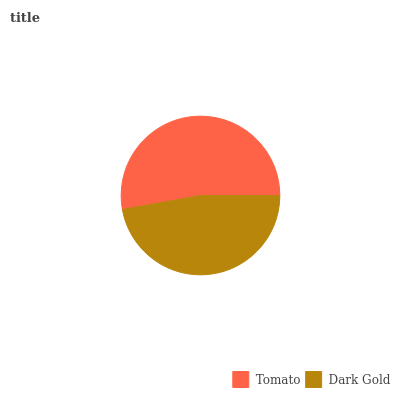Is Dark Gold the minimum?
Answer yes or no. Yes. Is Tomato the maximum?
Answer yes or no. Yes. Is Dark Gold the maximum?
Answer yes or no. No. Is Tomato greater than Dark Gold?
Answer yes or no. Yes. Is Dark Gold less than Tomato?
Answer yes or no. Yes. Is Dark Gold greater than Tomato?
Answer yes or no. No. Is Tomato less than Dark Gold?
Answer yes or no. No. Is Tomato the high median?
Answer yes or no. Yes. Is Dark Gold the low median?
Answer yes or no. Yes. Is Dark Gold the high median?
Answer yes or no. No. Is Tomato the low median?
Answer yes or no. No. 